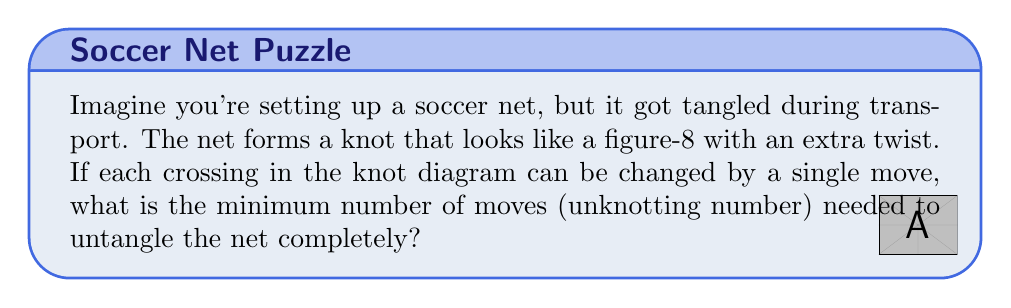Provide a solution to this math problem. Let's approach this step-by-step:

1) First, we need to understand what we're dealing with. The description suggests a figure-8 knot with an extra twist, which is known in knot theory as the "trefoil knot".

2) The trefoil knot is one of the simplest non-trivial knots. It has a crossing number of 3, meaning it has three crossings in its minimal diagram.

3) The unknotting number of a knot is the minimum number of times the knot must pass through itself to become unknotted. For the trefoil knot, this number is known to be 1.

4) To visualize this, we can represent the trefoil knot as:

   [asy]
   import geometry;
   
   size(100);
   
   path p = (0,0)..(1,1)..(2,0)..(1,-1)..cycle;
   path q = rotate(120)*p;
   path r = rotate(240)*p;
   
   draw(p);
   draw(q);
   draw(r);
   [/asy]

5) To unknot the trefoil, we only need to change one of the crossings. This single change will transform the knot into a simple loop, which is equivalent to an unknot.

6) Therefore, the unknotting number for this "twisted soccer net" is 1.
Answer: 1 